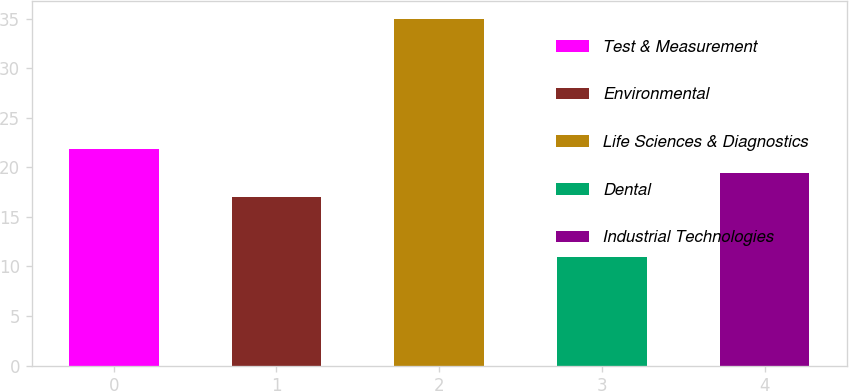Convert chart. <chart><loc_0><loc_0><loc_500><loc_500><bar_chart><fcel>Test & Measurement<fcel>Environmental<fcel>Life Sciences & Diagnostics<fcel>Dental<fcel>Industrial Technologies<nl><fcel>21.8<fcel>17<fcel>35<fcel>11<fcel>19.4<nl></chart> 